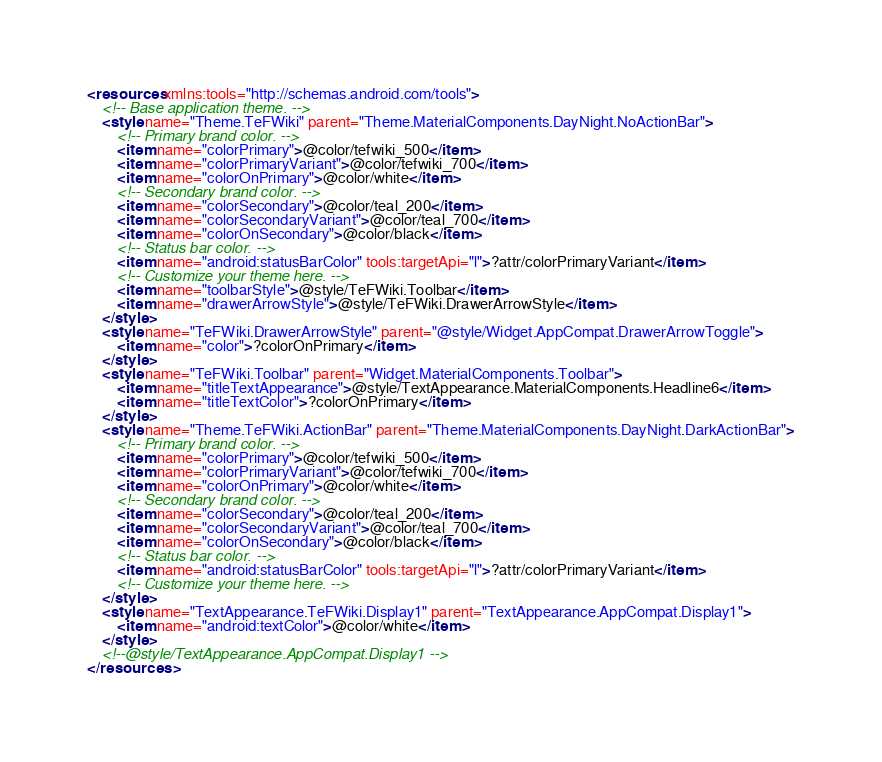<code> <loc_0><loc_0><loc_500><loc_500><_XML_><resources xmlns:tools="http://schemas.android.com/tools">
    <!-- Base application theme. -->
    <style name="Theme.TeFWiki" parent="Theme.MaterialComponents.DayNight.NoActionBar">
        <!-- Primary brand color. -->
        <item name="colorPrimary">@color/tefwiki_500</item>
        <item name="colorPrimaryVariant">@color/tefwiki_700</item>
        <item name="colorOnPrimary">@color/white</item>
        <!-- Secondary brand color. -->
        <item name="colorSecondary">@color/teal_200</item>
        <item name="colorSecondaryVariant">@color/teal_700</item>
        <item name="colorOnSecondary">@color/black</item>
        <!-- Status bar color. -->
        <item name="android:statusBarColor" tools:targetApi="l">?attr/colorPrimaryVariant</item>
        <!-- Customize your theme here. -->
        <item name="toolbarStyle">@style/TeFWiki.Toolbar</item>
        <item name="drawerArrowStyle">@style/TeFWiki.DrawerArrowStyle</item>
    </style>
    <style name="TeFWiki.DrawerArrowStyle" parent="@style/Widget.AppCompat.DrawerArrowToggle">
        <item name="color">?colorOnPrimary</item>
    </style>
    <style name="TeFWiki.Toolbar" parent="Widget.MaterialComponents.Toolbar">
        <item name="titleTextAppearance">@style/TextAppearance.MaterialComponents.Headline6</item>
        <item name="titleTextColor">?colorOnPrimary</item>
    </style>
    <style name="Theme.TeFWiki.ActionBar" parent="Theme.MaterialComponents.DayNight.DarkActionBar">
        <!-- Primary brand color. -->
        <item name="colorPrimary">@color/tefwiki_500</item>
        <item name="colorPrimaryVariant">@color/tefwiki_700</item>
        <item name="colorOnPrimary">@color/white</item>
        <!-- Secondary brand color. -->
        <item name="colorSecondary">@color/teal_200</item>
        <item name="colorSecondaryVariant">@color/teal_700</item>
        <item name="colorOnSecondary">@color/black</item>
        <!-- Status bar color. -->
        <item name="android:statusBarColor" tools:targetApi="l">?attr/colorPrimaryVariant</item>
        <!-- Customize your theme here. -->
    </style>
    <style name="TextAppearance.TeFWiki.Display1" parent="TextAppearance.AppCompat.Display1">
        <item name="android:textColor">@color/white</item>
    </style>
    <!--@style/TextAppearance.AppCompat.Display1 -->
</resources></code> 